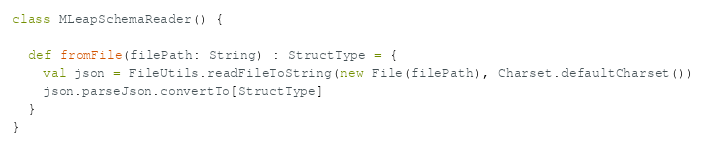<code> <loc_0><loc_0><loc_500><loc_500><_Scala_>class MLeapSchemaReader() {

  def fromFile(filePath: String) : StructType = {
    val json = FileUtils.readFileToString(new File(filePath), Charset.defaultCharset())
    json.parseJson.convertTo[StructType]
  }
}
</code> 